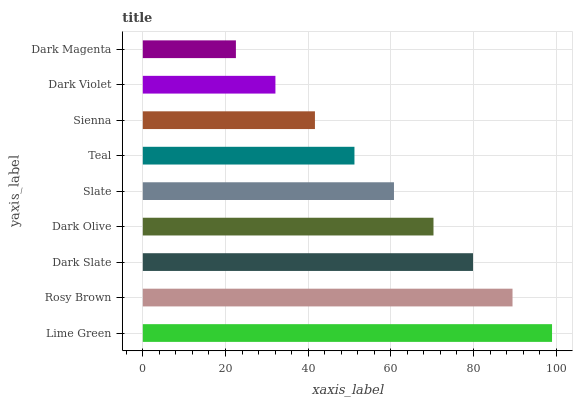Is Dark Magenta the minimum?
Answer yes or no. Yes. Is Lime Green the maximum?
Answer yes or no. Yes. Is Rosy Brown the minimum?
Answer yes or no. No. Is Rosy Brown the maximum?
Answer yes or no. No. Is Lime Green greater than Rosy Brown?
Answer yes or no. Yes. Is Rosy Brown less than Lime Green?
Answer yes or no. Yes. Is Rosy Brown greater than Lime Green?
Answer yes or no. No. Is Lime Green less than Rosy Brown?
Answer yes or no. No. Is Slate the high median?
Answer yes or no. Yes. Is Slate the low median?
Answer yes or no. Yes. Is Rosy Brown the high median?
Answer yes or no. No. Is Teal the low median?
Answer yes or no. No. 